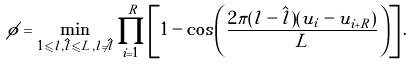Convert formula to latex. <formula><loc_0><loc_0><loc_500><loc_500>\phi = \min _ { 1 \leqslant l , \hat { l } \leqslant L , l \neq \hat { l } } \prod _ { i = 1 } ^ { R } \left [ 1 - \cos \left ( \frac { 2 \pi ( l - \hat { l } ) ( u _ { i } - u _ { i + R } ) } { L } \right ) \right ] .</formula> 